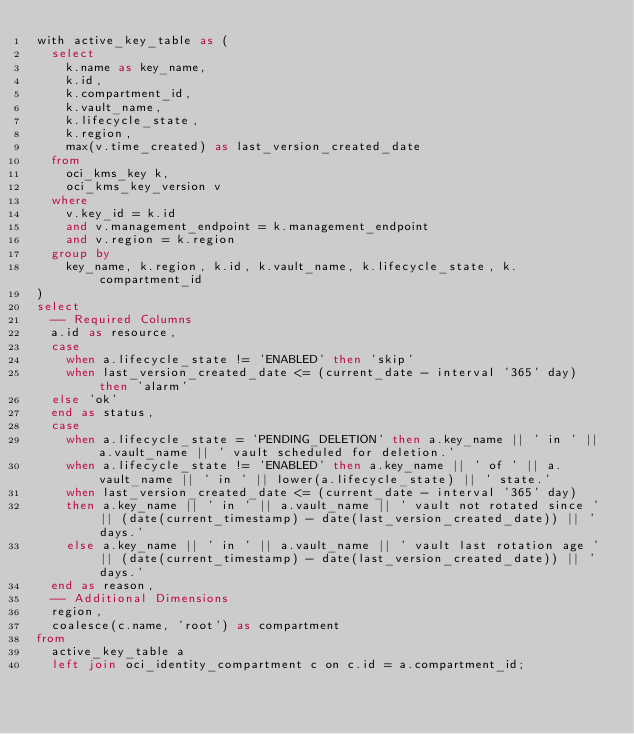<code> <loc_0><loc_0><loc_500><loc_500><_SQL_>with active_key_table as (
  select
    k.name as key_name,
    k.id,
    k.compartment_id,
    k.vault_name,
    k.lifecycle_state,
    k.region,
    max(v.time_created) as last_version_created_date
  from
    oci_kms_key k,
    oci_kms_key_version v
  where
    v.key_id = k.id
    and v.management_endpoint = k.management_endpoint
    and v.region = k.region
  group by
    key_name, k.region, k.id, k.vault_name, k.lifecycle_state, k.compartment_id
)
select
  -- Required Columns
  a.id as resource,
  case
    when a.lifecycle_state != 'ENABLED' then 'skip'
    when last_version_created_date <= (current_date - interval '365' day) then 'alarm'
  else 'ok'
  end as status,
  case
    when a.lifecycle_state = 'PENDING_DELETION' then a.key_name || ' in ' || a.vault_name || ' vault scheduled for deletion.'
    when a.lifecycle_state != 'ENABLED' then a.key_name || ' of ' || a.vault_name || ' in ' || lower(a.lifecycle_state) || ' state.'
    when last_version_created_date <= (current_date - interval '365' day)
    then a.key_name || ' in ' || a.vault_name || ' vault not rotated since ' || (date(current_timestamp) - date(last_version_created_date)) || ' days.'
    else a.key_name || ' in ' || a.vault_name || ' vault last rotation age ' || (date(current_timestamp) - date(last_version_created_date)) || ' days.'
  end as reason,
  -- Additional Dimensions
  region,
  coalesce(c.name, 'root') as compartment
from
  active_key_table a
  left join oci_identity_compartment c on c.id = a.compartment_id;</code> 